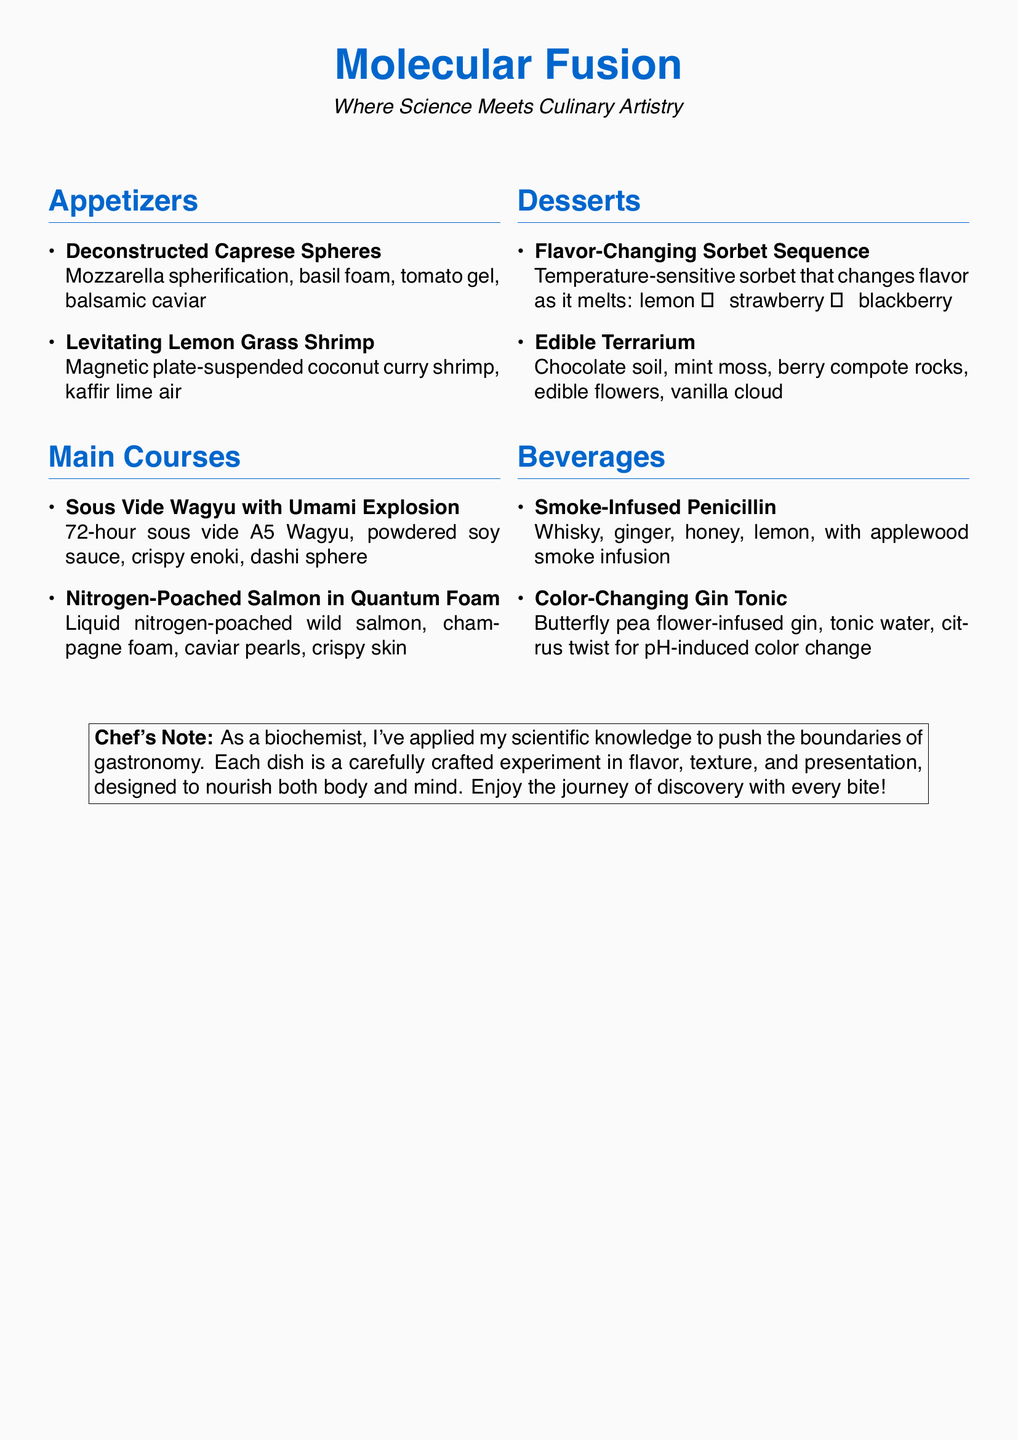What is the name of the appetizer featuring mozzarella? The appetizer featuring mozzarella is called "Deconstructed Caprese Spheres."
Answer: Deconstructed Caprese Spheres How long is the sous vide Wagyu cooked for? The sous vide Wagyu is cooked for 72 hours.
Answer: 72 hours What kind of tree wood is used for smoking in the beverage? The beverage uses applewood for smoking.
Answer: Applewood Which dish features a temperature-sensitive sorbet? The dish that features a temperature-sensitive sorbet is "Flavor-Changing Sorbet Sequence."
Answer: Flavor-Changing Sorbet Sequence What is a unique characteristic of the "Levitating Lemon Grass Shrimp"? The unique characteristic is that it is suspended on a magnetic plate.
Answer: Magnetic plate-suspended How many main courses are listed on the menu? There are four main courses listed on the menu.
Answer: Four What ingredient changes color in the "Color-Changing Gin Tonic"? The ingredient that changes color is the butterfly pea flower-infused gin.
Answer: Butterfly pea flower-infused gin Which dessert includes edible flowers? The dessert that includes edible flowers is "Edible Terrarium."
Answer: Edible Terrarium What is the theme of the restaurant as indicated in the title? The theme of the restaurant is "Molecular Fusion."
Answer: Molecular Fusion 